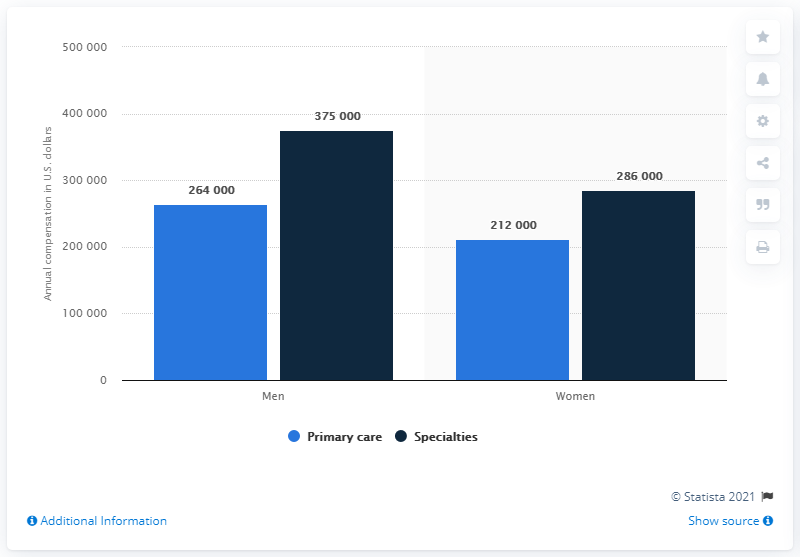Draw attention to some important aspects in this diagram. The average value represented in the blue bar chart is approximately 238,000. In the United States, the average annual compensation for female primary care physicians was approximately $212,000 in 2020. The average annual compensation for male primary care physicians was 264,000. The highest value in the chart is 375,000. 